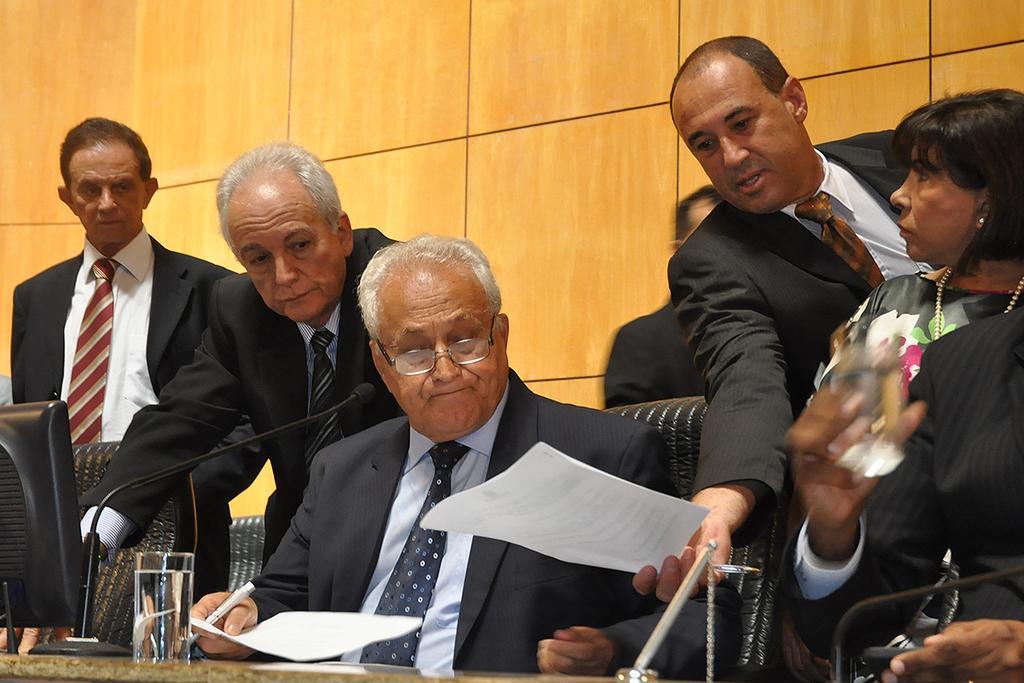How would you summarize this image in a sentence or two? There are people standing and this man sitting on chair and holding paper and pen. We can see microphones, glass, monitor and objects on the table and chairs. In the background we can see wooden wall. 